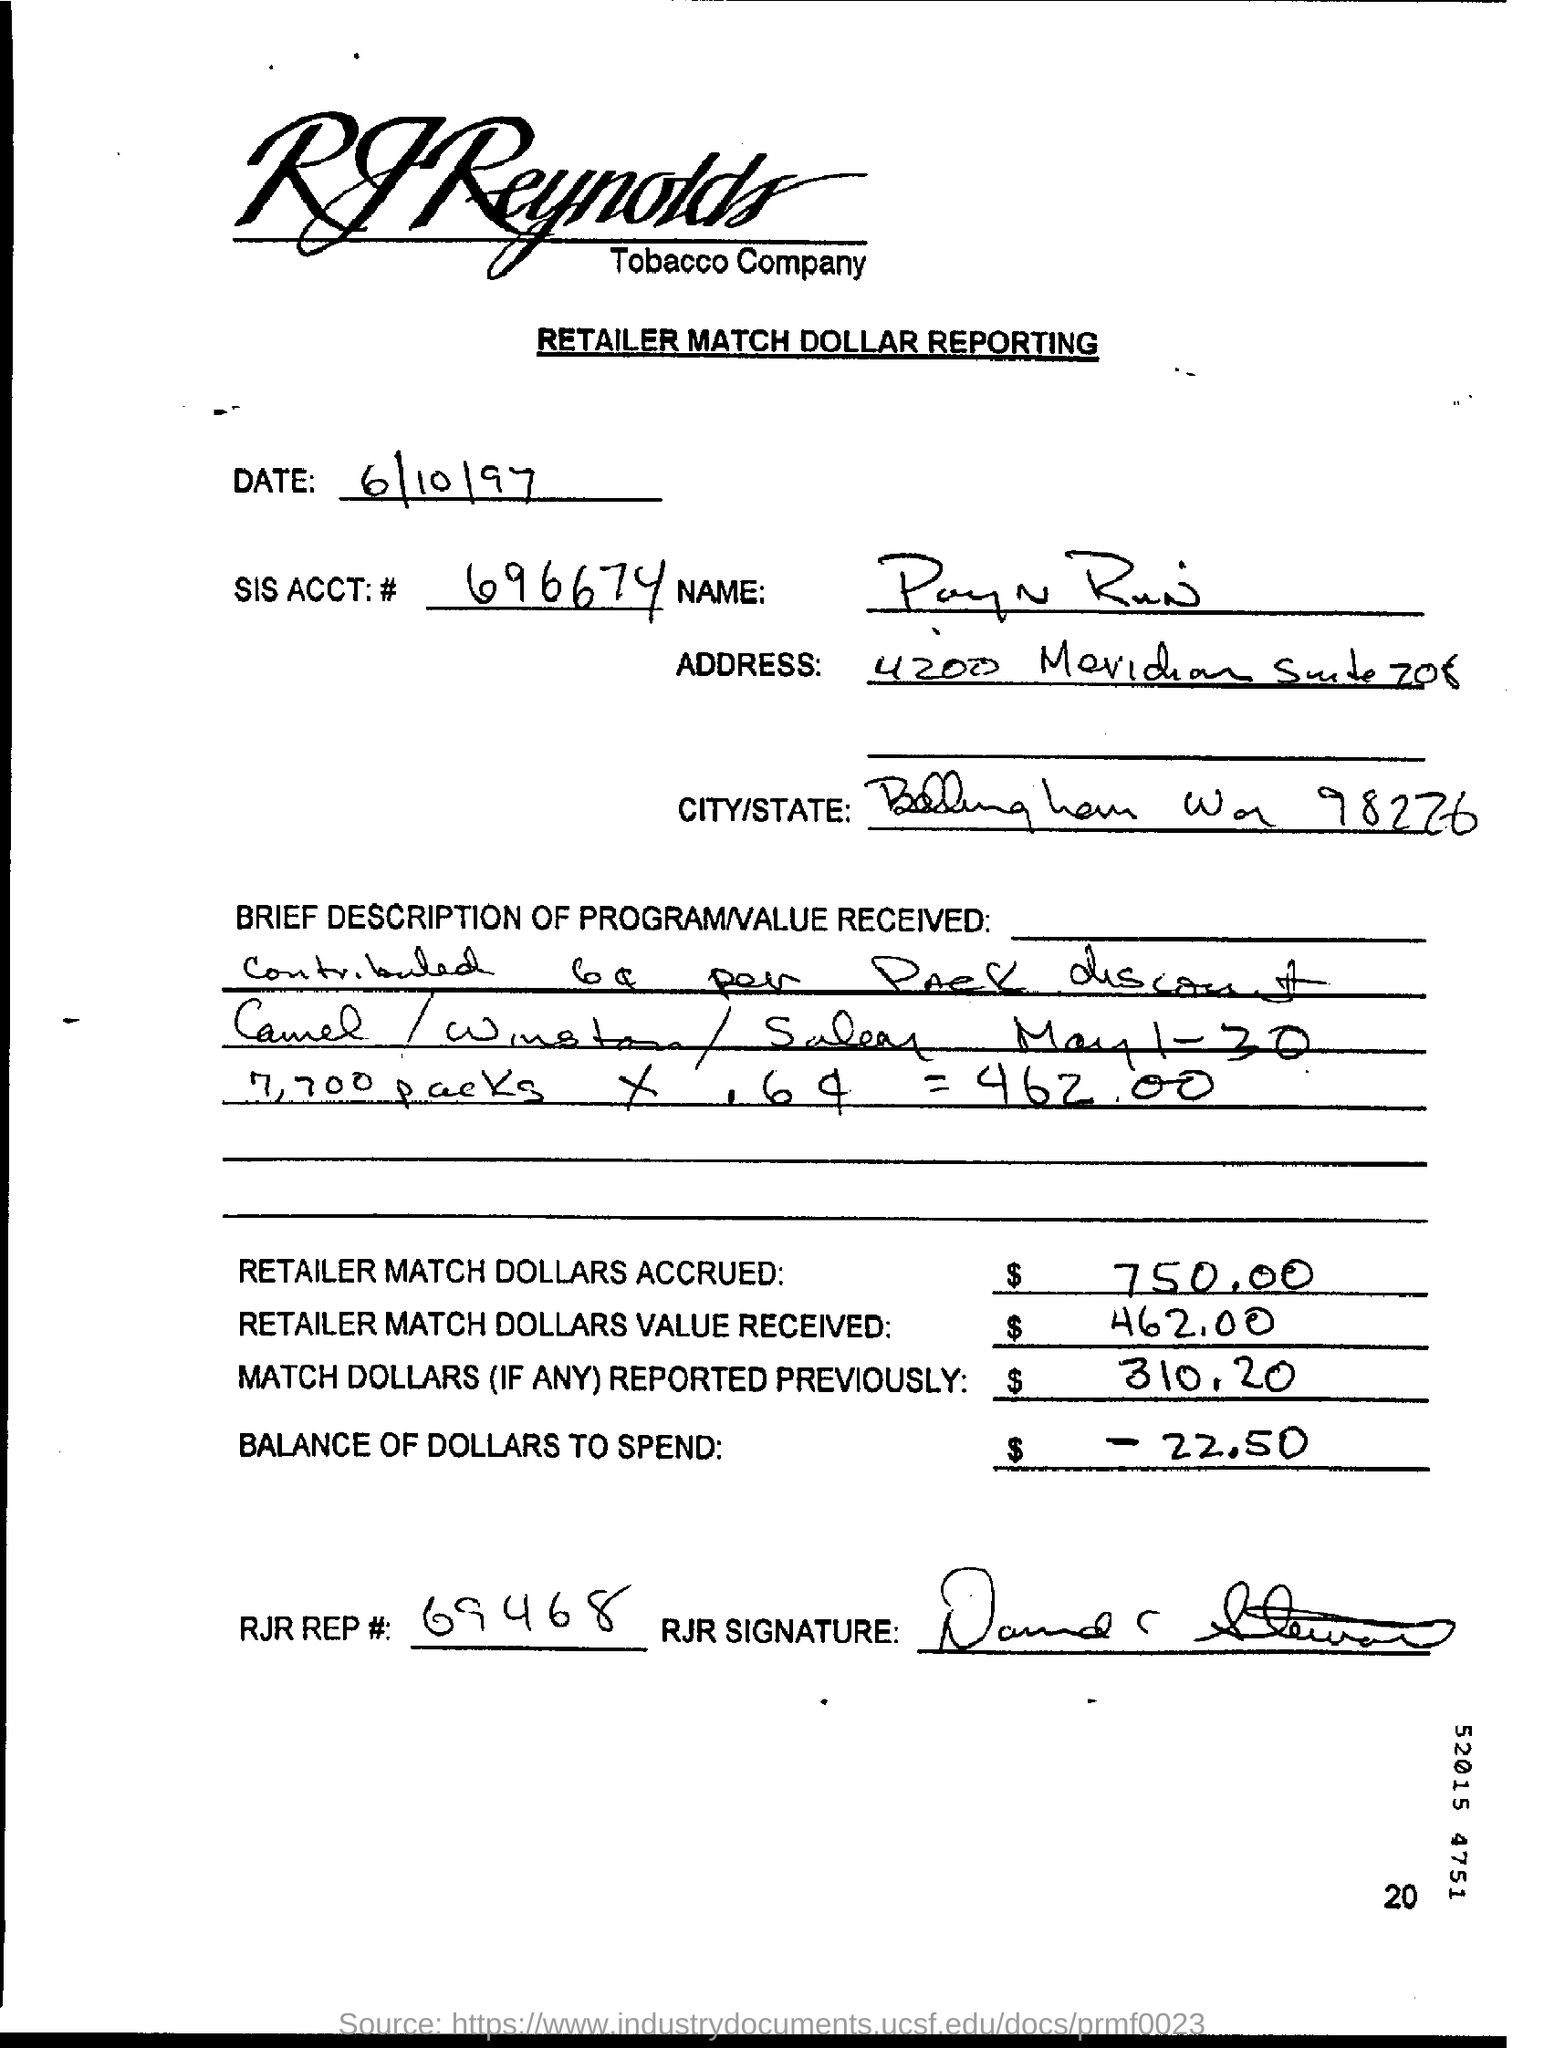What is the sis acct:# number
Your answer should be compact. 696674. Value of retailer match dollars accrued
Keep it short and to the point. $ 750.00. What is the retailer match dollars value received
Offer a very short reply. 462.00. What is the rjp rep#:
Offer a very short reply. 69468. 